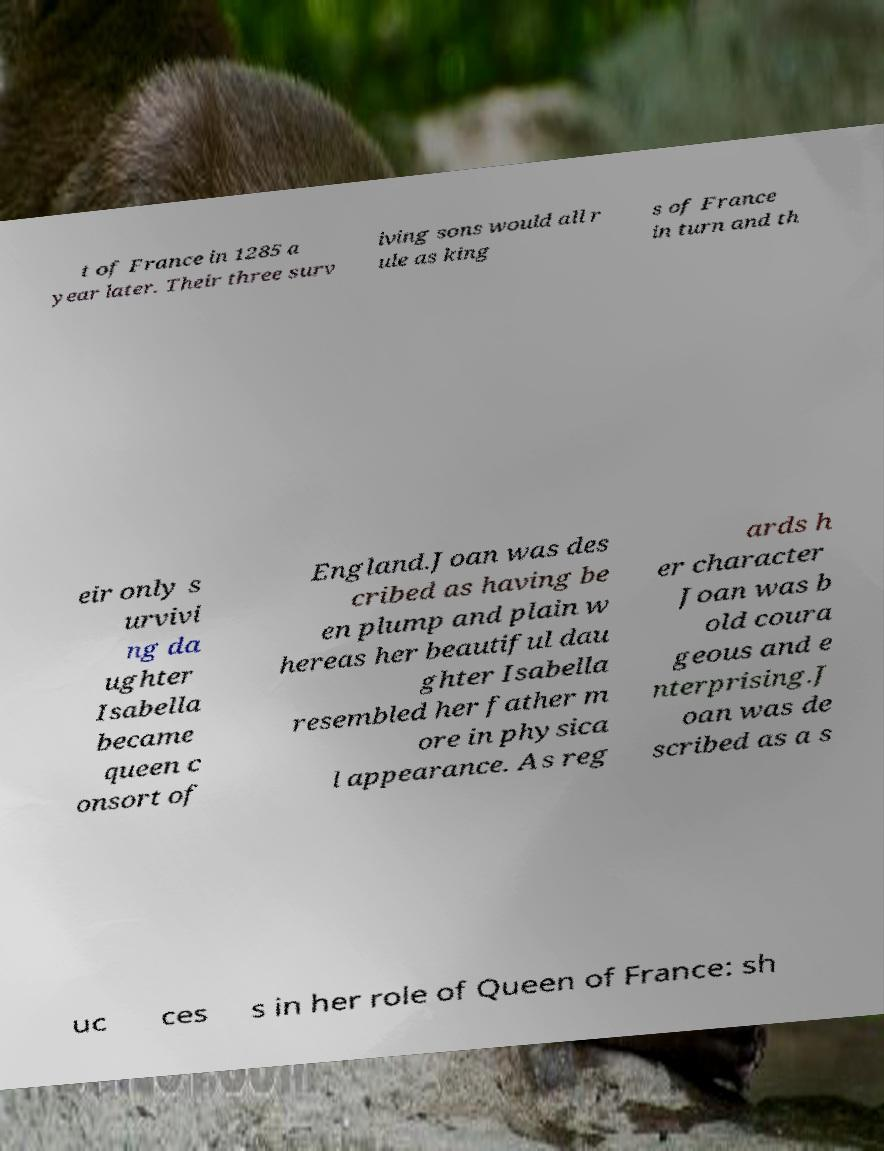I need the written content from this picture converted into text. Can you do that? t of France in 1285 a year later. Their three surv iving sons would all r ule as king s of France in turn and th eir only s urvivi ng da ughter Isabella became queen c onsort of England.Joan was des cribed as having be en plump and plain w hereas her beautiful dau ghter Isabella resembled her father m ore in physica l appearance. As reg ards h er character Joan was b old coura geous and e nterprising.J oan was de scribed as a s uc ces s in her role of Queen of France: sh 